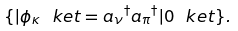<formula> <loc_0><loc_0><loc_500><loc_500>\{ | \phi _ { \kappa } \ k e t = { a _ { \nu } } ^ { \dagger } { a _ { \pi } } ^ { \dagger } | 0 \ k e t \} .</formula> 